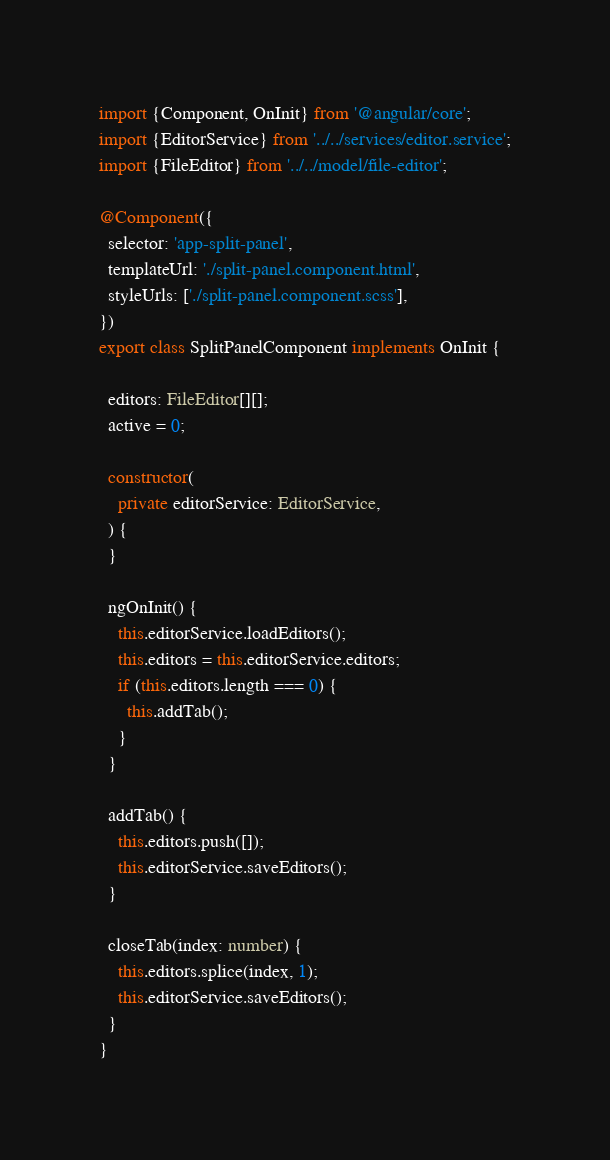<code> <loc_0><loc_0><loc_500><loc_500><_TypeScript_>import {Component, OnInit} from '@angular/core';
import {EditorService} from '../../services/editor.service';
import {FileEditor} from '../../model/file-editor';

@Component({
  selector: 'app-split-panel',
  templateUrl: './split-panel.component.html',
  styleUrls: ['./split-panel.component.scss'],
})
export class SplitPanelComponent implements OnInit {

  editors: FileEditor[][];
  active = 0;

  constructor(
    private editorService: EditorService,
  ) {
  }

  ngOnInit() {
    this.editorService.loadEditors();
    this.editors = this.editorService.editors;
    if (this.editors.length === 0) {
      this.addTab();
    }
  }

  addTab() {
    this.editors.push([]);
    this.editorService.saveEditors();
  }

  closeTab(index: number) {
    this.editors.splice(index, 1);
    this.editorService.saveEditors();
  }
}
</code> 